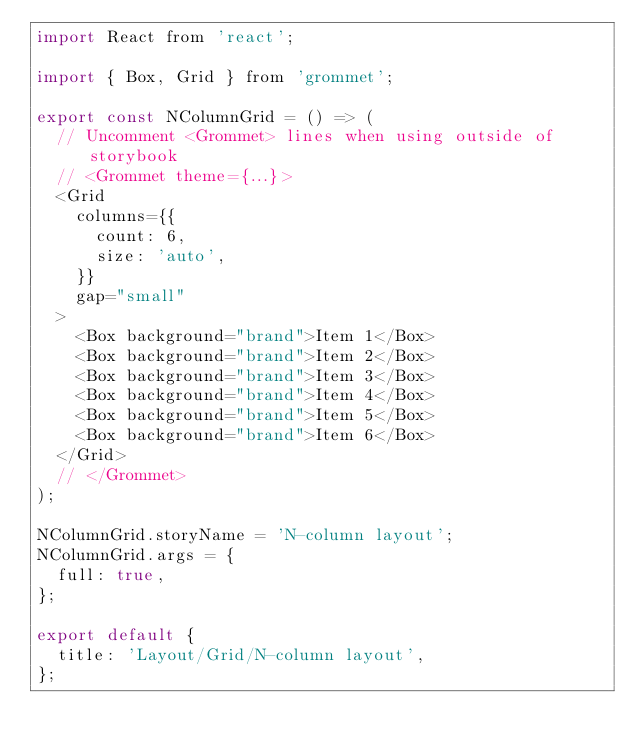<code> <loc_0><loc_0><loc_500><loc_500><_JavaScript_>import React from 'react';

import { Box, Grid } from 'grommet';

export const NColumnGrid = () => (
  // Uncomment <Grommet> lines when using outside of storybook
  // <Grommet theme={...}>
  <Grid
    columns={{
      count: 6,
      size: 'auto',
    }}
    gap="small"
  >
    <Box background="brand">Item 1</Box>
    <Box background="brand">Item 2</Box>
    <Box background="brand">Item 3</Box>
    <Box background="brand">Item 4</Box>
    <Box background="brand">Item 5</Box>
    <Box background="brand">Item 6</Box>
  </Grid>
  // </Grommet>
);

NColumnGrid.storyName = 'N-column layout';
NColumnGrid.args = {
  full: true,
};

export default {
  title: 'Layout/Grid/N-column layout',
};
</code> 